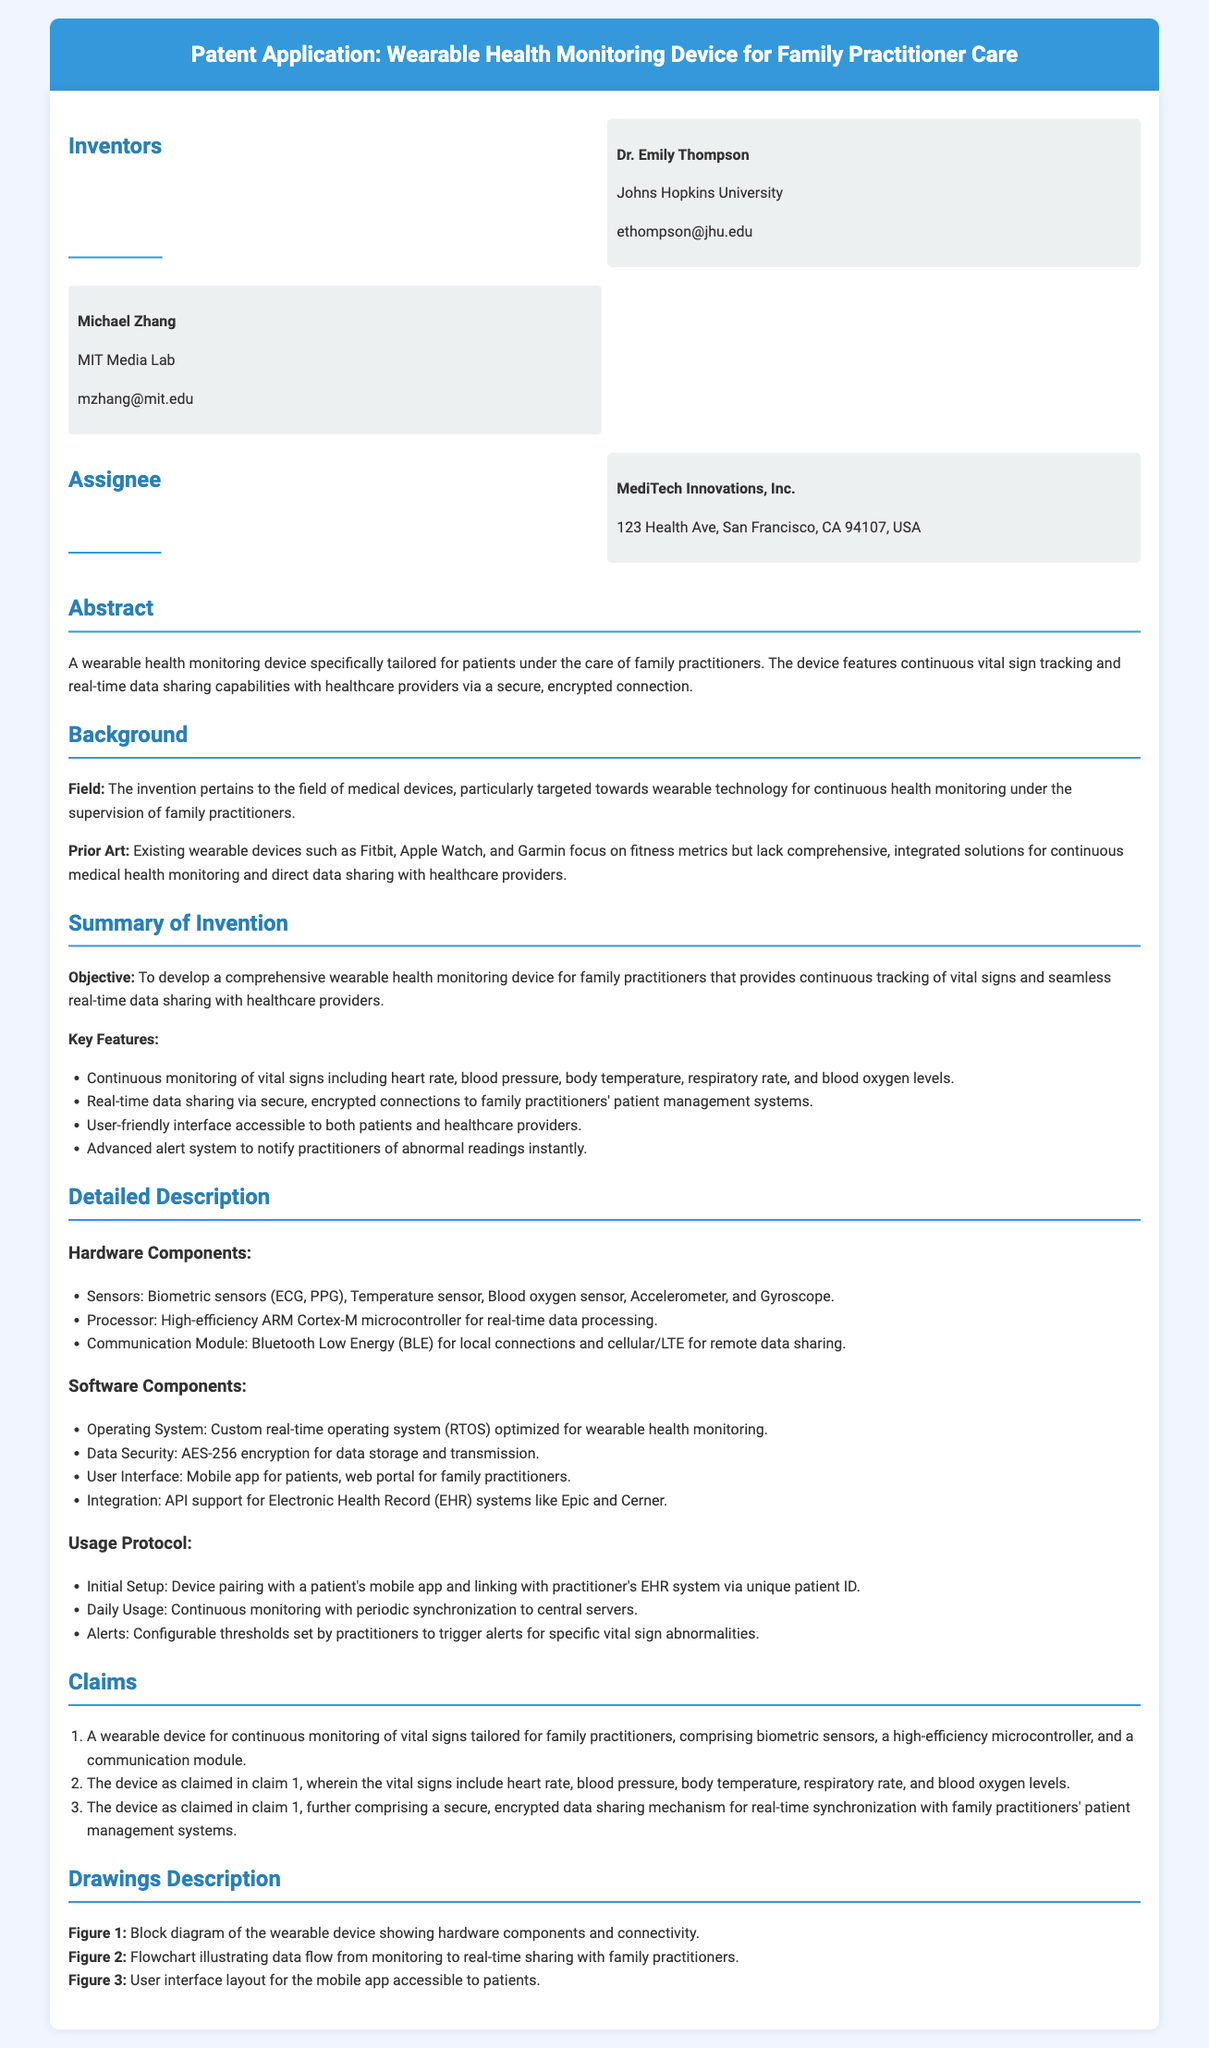What is the name of one inventor of the device? The document lists two inventors, one of them being Dr. Emily Thompson.
Answer: Dr. Emily Thompson What company is the assignee of the patent? The assignee mentioned in the patent is MediTech Innovations, Inc.
Answer: MediTech Innovations, Inc What is one of the vital signs monitored by the device? The device continuously monitors several vital signs including heart rate, which is one of them.
Answer: Heart rate What technology is used for real-time data sharing? The document states that the device uses secure, encrypted connections for real-time data sharing.
Answer: Secure, encrypted connections How many claims are listed in the patent application? There are three claims detailed in the claims section of the application.
Answer: Three What kind of processor does the device utilize? The document specifies that the device uses a high-efficiency ARM Cortex-M microcontroller.
Answer: ARM Cortex-M microcontroller What user interface is mentioned for patients? A mobile app is specified as the user interface accessible to patients.
Answer: Mobile app What security feature is employed for data transmission? The patent describes the use of AES-256 encryption for secure data transmission.
Answer: AES-256 encryption What is the primary objective of the invention? The objective is to develop a comprehensive device for family practitioners providing continuous health monitoring.
Answer: Comprehensive wearable health monitoring device 